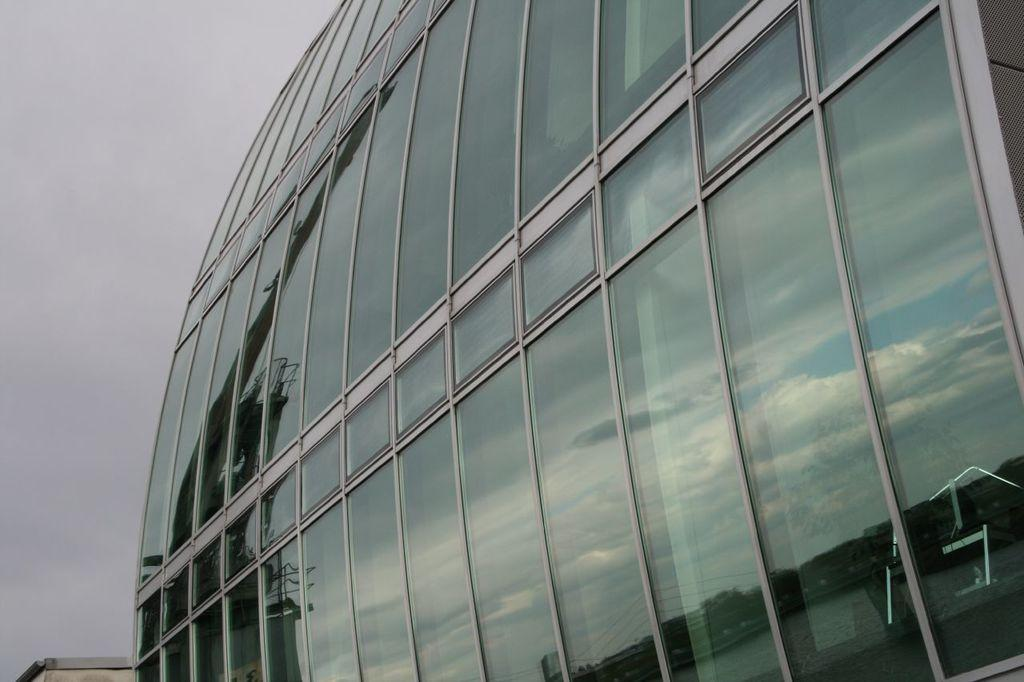What type of building is shown in the image? There is a huge glass corporate building in the image. What can be seen in the background of the image? There is a blue sky visible in the image. What committee is responsible for the action of the line in the image? There is no committee, action, or line present in the image. 